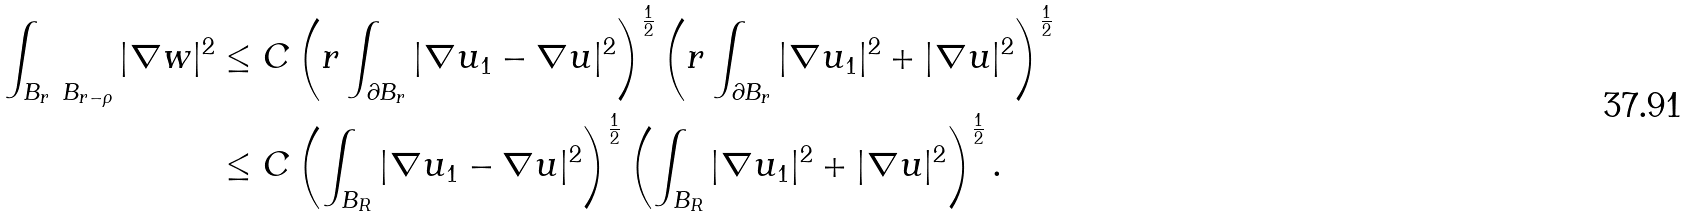Convert formula to latex. <formula><loc_0><loc_0><loc_500><loc_500>\int _ { B _ { r } \ B _ { r - \rho } } | \nabla w | ^ { 2 } & \leq C \left ( r \int _ { \partial B _ { r } } | \nabla u _ { 1 } - \nabla u | ^ { 2 } \right ) ^ { \frac { 1 } { 2 } } \left ( r \int _ { \partial B _ { r } } | \nabla u _ { 1 } | ^ { 2 } + | \nabla u | ^ { 2 } \right ) ^ { \frac { 1 } { 2 } } \\ & \leq C \left ( \int _ { B _ { R } } | \nabla u _ { 1 } - \nabla u | ^ { 2 } \right ) ^ { \frac { 1 } { 2 } } \left ( \int _ { B _ { R } } | \nabla u _ { 1 } | ^ { 2 } + | \nabla u | ^ { 2 } \right ) ^ { \frac { 1 } { 2 } } .</formula> 